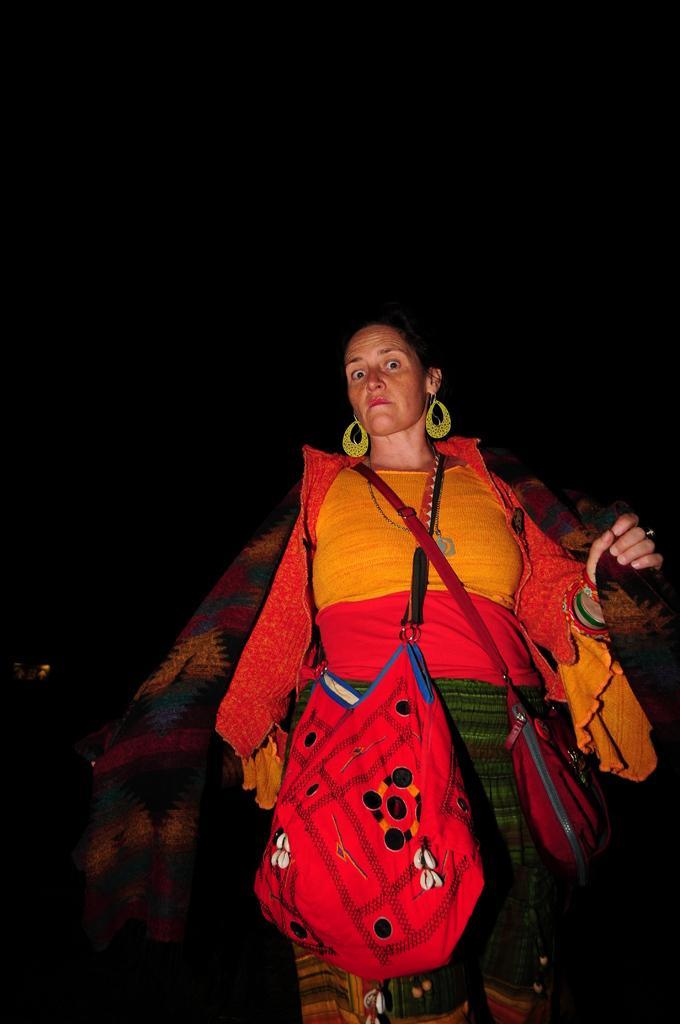Can you describe this image briefly? There is one woman wearing a jacket and a side bag as we can see at the bottom of this image. It is dark in the background. 